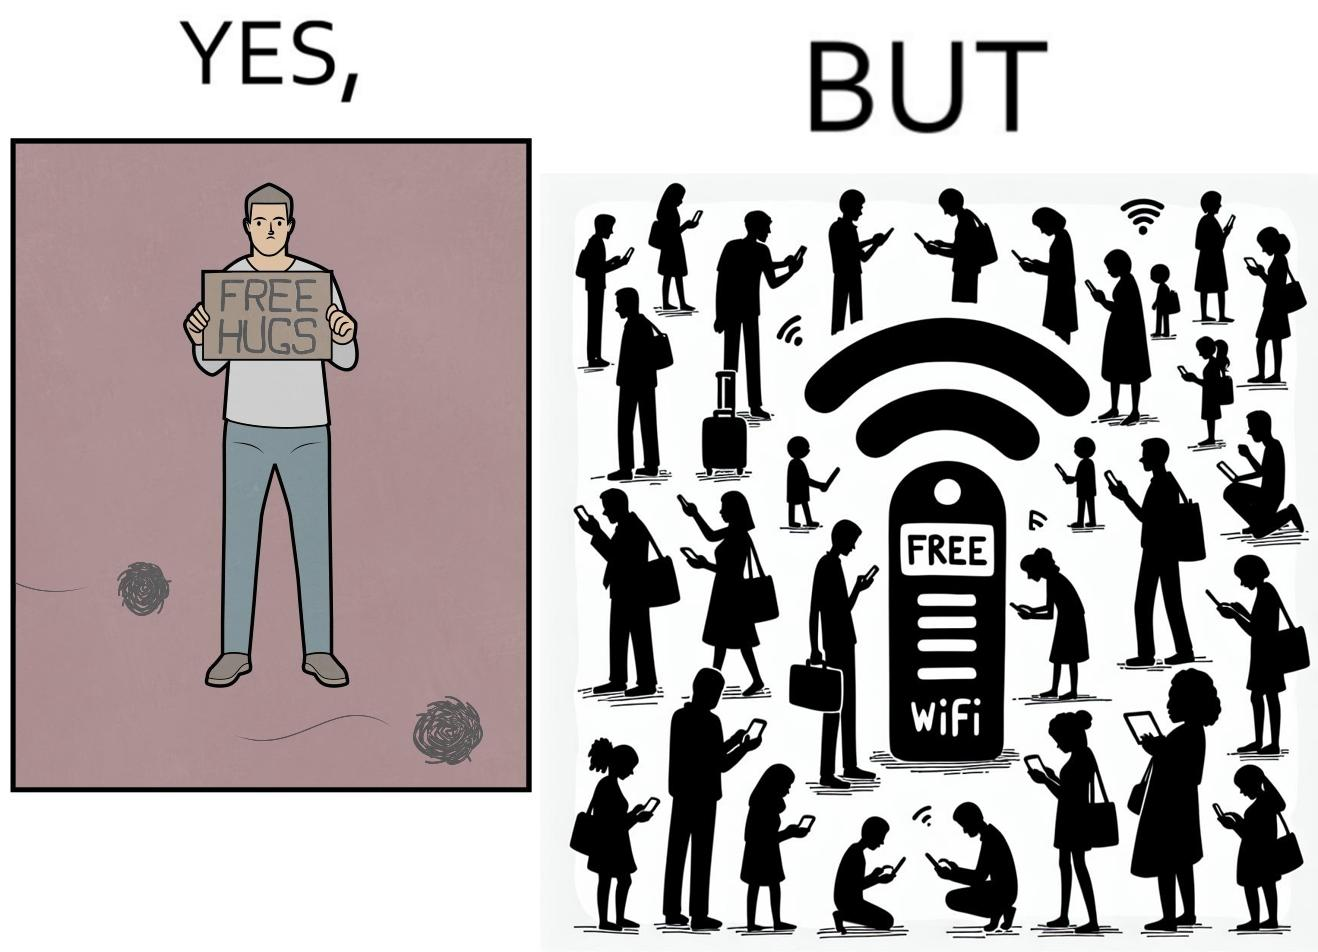What do you see in each half of this image? In the left part of the image: a person standing alone holding a sign "Free Hugs". The tumbleweeds blowing in the wind further stress on the loneliness. In the right part of the image: A Wi-fi Router with the label "Free Wifi" in front of it, surrounded by people trying to connect to it on their mobile devices. 